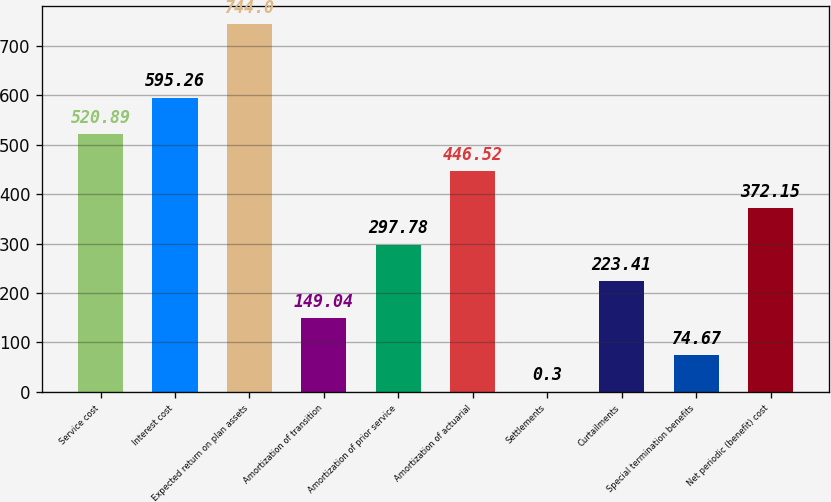Convert chart to OTSL. <chart><loc_0><loc_0><loc_500><loc_500><bar_chart><fcel>Service cost<fcel>Interest cost<fcel>Expected return on plan assets<fcel>Amortization of transition<fcel>Amortization of prior service<fcel>Amortization of actuarial<fcel>Settlements<fcel>Curtailments<fcel>Special termination benefits<fcel>Net periodic (benefit) cost<nl><fcel>520.89<fcel>595.26<fcel>744<fcel>149.04<fcel>297.78<fcel>446.52<fcel>0.3<fcel>223.41<fcel>74.67<fcel>372.15<nl></chart> 